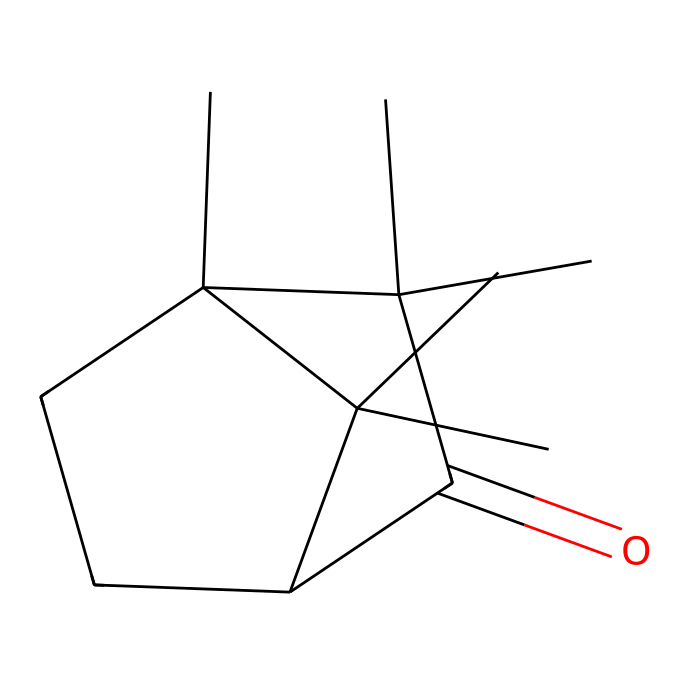What is the molecular formula of camphor? To determine the molecular formula, we decode the SMILES representation, which shows various carbon and oxygen atoms. Counting the atoms reveals 10 carbon (C) atoms and 2 oxygen (O) atoms. Thus, the molecular formula is C10H16O.
Answer: C10H16O How many rings are present in camphor? Analyzing the structure, we identify cyclic components. The SMILES indicates two distinct cycles due to the branched structures depicted. Thus, there are 2 rings in the structure.
Answer: 2 What type of functional group is present in camphor? In the SMILES representation, the "C(=O)" indicates the presence of a carbonyl group, which is characteristic of ketones. This functional group confirms camphor's classification as a ketone.
Answer: ketone What is the total number of hydrogen atoms in camphor? By interpreting the SMILES notation and considering the bonds with carbon and the carbonyl, we can tally the hydrogen atoms attached to carbon atoms. The total count confirms there are 16 hydrogen (H) atoms.
Answer: 16 Is camphor a saturated or unsaturated compound? The presence of double bonds in the structure (specifically in the carbonyl group) indicates that it is not fully saturated with hydrogen. Hence, camphor is classified as an unsaturated compound.
Answer: unsaturated How many carbon atoms are branching off the main structure in camphor? By examining the main carbon chain and its attachments in the SMILES, we can identify the points of branching. There are 3 distinct carbon atoms branching off the main structure.
Answer: 3 